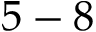<formula> <loc_0><loc_0><loc_500><loc_500>5 - 8</formula> 